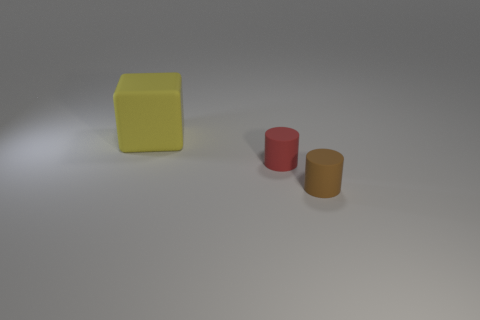There is a yellow object that is made of the same material as the small red cylinder; what is its shape?
Your answer should be very brief. Cube. Are there any other things that are the same color as the block?
Offer a terse response. No. What is the color of the small matte thing that is on the left side of the small matte object that is in front of the small red rubber object?
Ensure brevity in your answer.  Red. There is a thing to the right of the small cylinder left of the brown rubber object that is in front of the tiny red object; what is it made of?
Offer a terse response. Rubber. What number of red rubber objects have the same size as the yellow block?
Provide a short and direct response. 0. There is a thing that is in front of the large yellow block and behind the brown rubber cylinder; what is its material?
Offer a terse response. Rubber. There is a tiny brown rubber thing; how many small cylinders are in front of it?
Provide a succinct answer. 0. There is a large matte object; is its shape the same as the small matte object to the left of the brown thing?
Make the answer very short. No. Is there another tiny rubber object that has the same shape as the red rubber thing?
Your answer should be very brief. Yes. There is a object that is to the right of the small rubber thing that is behind the small brown matte cylinder; what shape is it?
Your answer should be compact. Cylinder. 